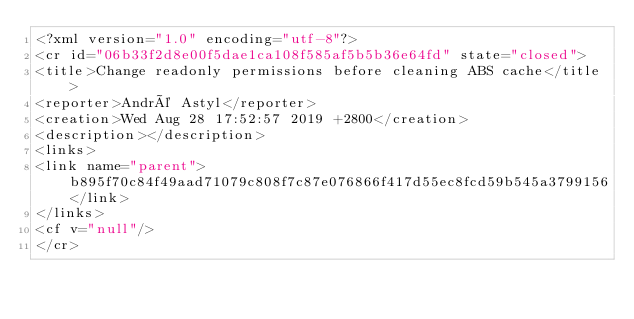Convert code to text. <code><loc_0><loc_0><loc_500><loc_500><_Crystal_><?xml version="1.0" encoding="utf-8"?>
<cr id="06b33f2d8e00f5dae1ca108f585af5b5b36e64fd" state="closed">
<title>Change readonly permissions before cleaning ABS cache</title>
<reporter>André Astyl</reporter>
<creation>Wed Aug 28 17:52:57 2019 +2800</creation>
<description></description>
<links>
<link name="parent">b895f70c84f49aad71079c808f7c87e076866f417d55ec8fcd59b545a3799156</link>
</links>
<cf v="null"/>
</cr>
</code> 